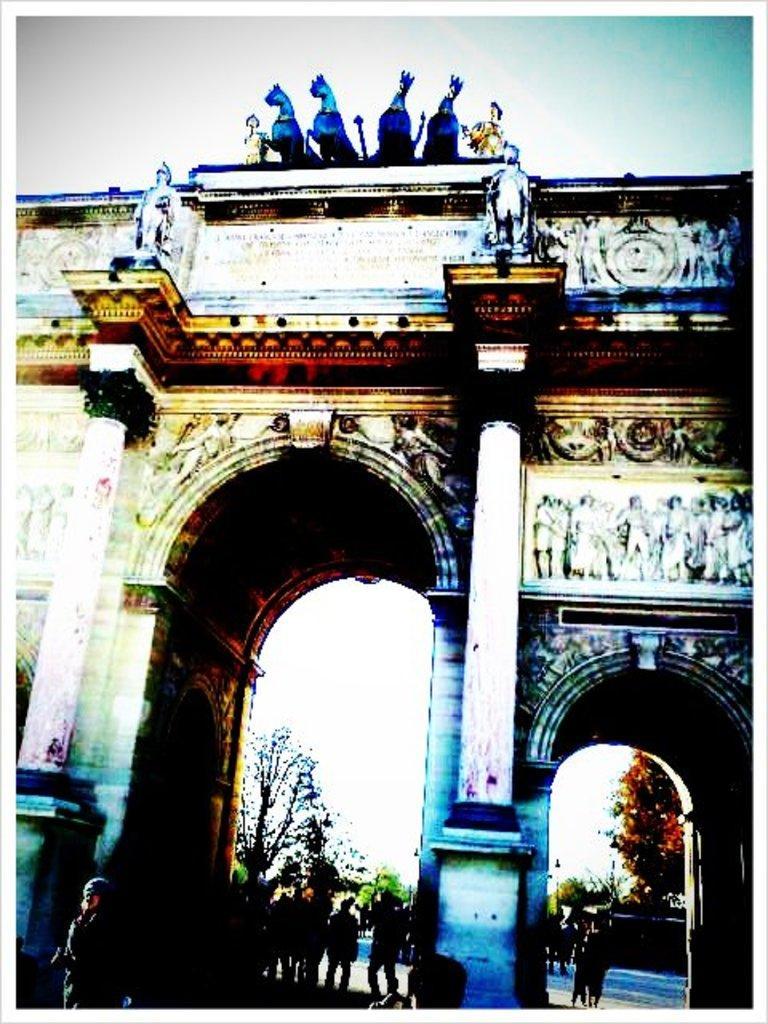In one or two sentences, can you explain what this image depicts? In this image I can see a building. Background I can see few other people standing, trees in green color, sky in white color. 